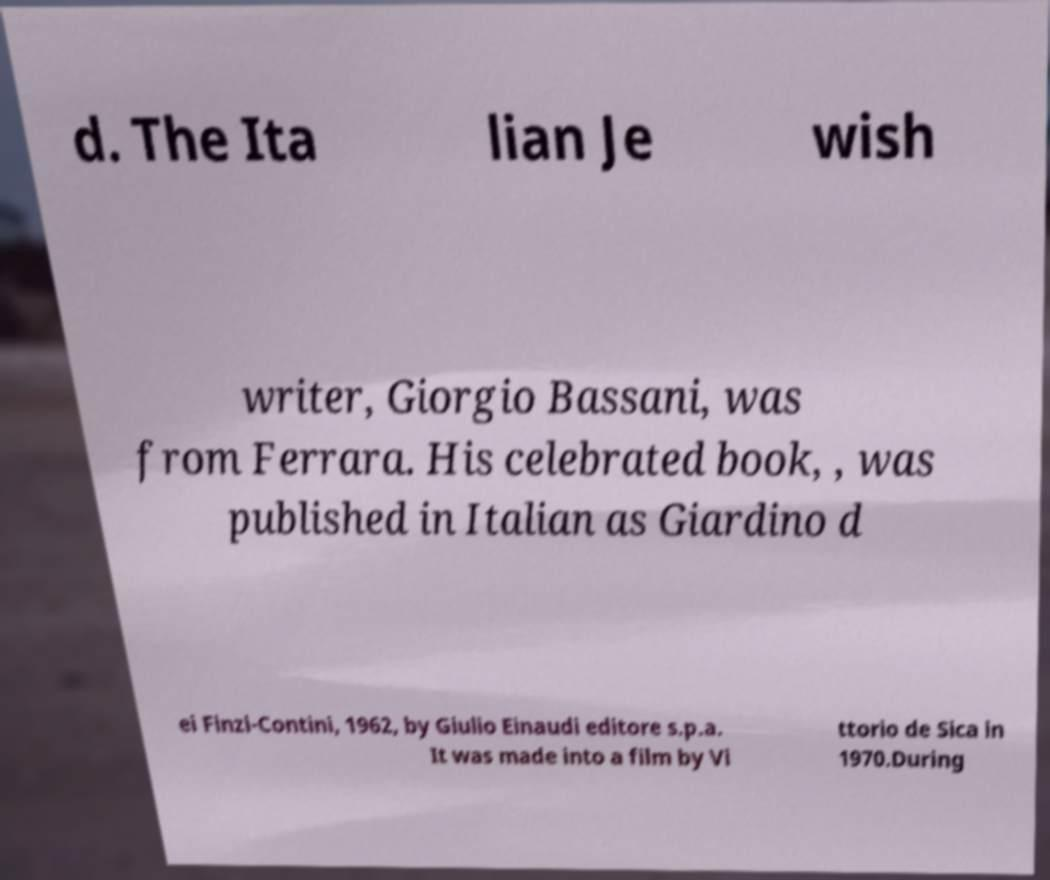Can you accurately transcribe the text from the provided image for me? d. The Ita lian Je wish writer, Giorgio Bassani, was from Ferrara. His celebrated book, , was published in Italian as Giardino d ei Finzi-Contini, 1962, by Giulio Einaudi editore s.p.a. It was made into a film by Vi ttorio de Sica in 1970.During 